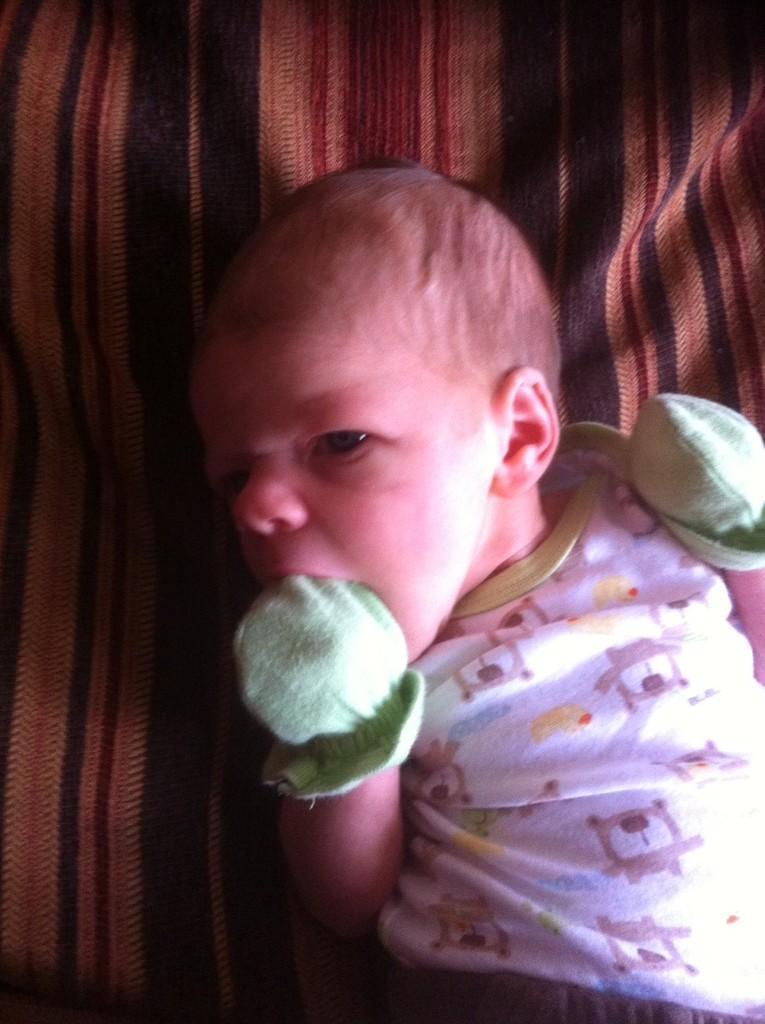In one or two sentences, can you explain what this image depicts? Baby is lying and wore gloves.  